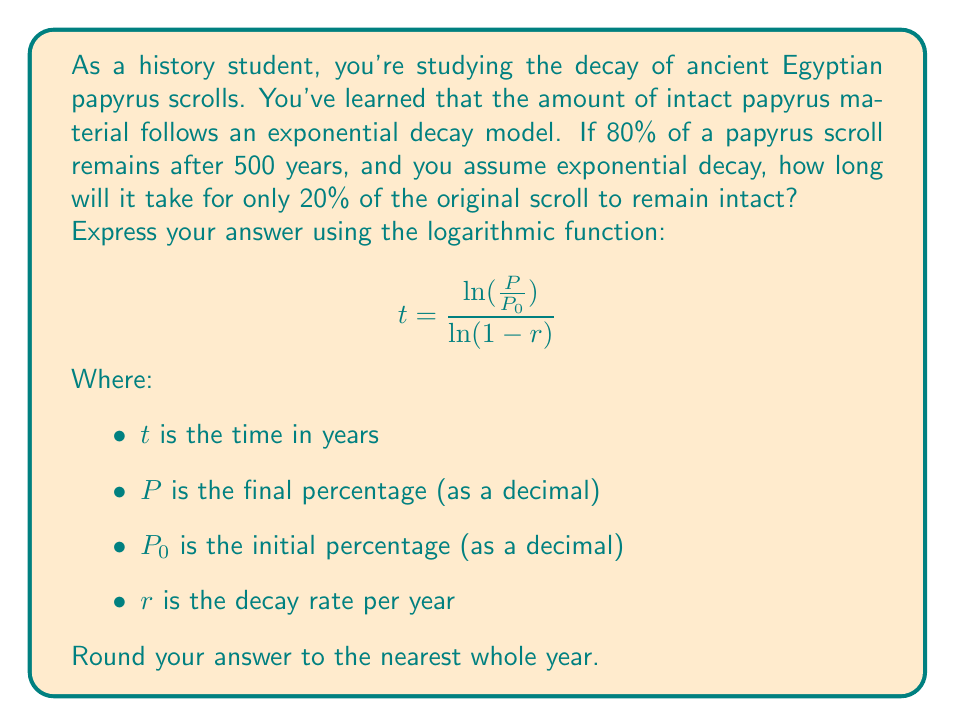Solve this math problem. To solve this problem, we'll follow these steps:

1. Determine the decay rate $r$ using the given information.
2. Use the logarithmic function to calculate the time for 20% to remain.

Step 1: Finding the decay rate $r$

We know that after 500 years, 80% of the scroll remains. Let's use the exponential decay formula:

$$P = P_0(1-r)^t$$

Where $P_0 = 1$ (100% at the start), $P = 0.8$ (80% after 500 years), and $t = 500$

$$0.8 = 1(1-r)^{500}$$

Taking the 500th root of both sides:

$$(0.8)^{\frac{1}{500}} = 1-r$$

$$r = 1 - (0.8)^{\frac{1}{500}} \approx 0.000446$$

Step 2: Calculating time for 20% to remain

Now we can use the logarithmic function given in the question:

$$t = \frac{\ln(\frac{P}{P_0})}{\ln(1-r)}$$

Where $P = 0.2$ (20% remaining), $P_0 = 1$ (100% at the start), and $r = 0.000446$

$$t = \frac{\ln(\frac{0.2}{1})}{\ln(1-0.000446)}$$

$$t = \frac{\ln(0.2)}{\ln(0.999554)}$$

$$t \approx 3609.78$$

Rounding to the nearest whole year, we get 3610 years.
Answer: 3610 years 